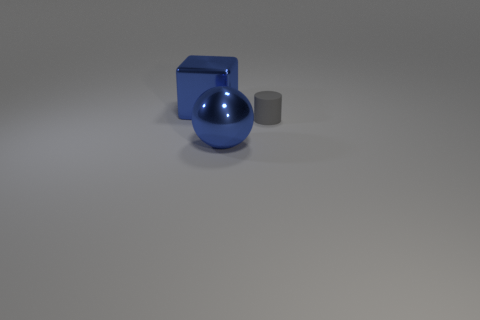Are there any tiny rubber objects in front of the gray matte object?
Keep it short and to the point. No. What shape is the big blue object that is on the left side of the metal thing in front of the gray rubber thing?
Your answer should be very brief. Cube. Are there fewer blue metal cubes that are right of the large blue metallic block than big blocks in front of the metal sphere?
Offer a very short reply. No. What number of things are left of the gray matte cylinder and right of the cube?
Provide a short and direct response. 1. Are there more spheres on the right side of the large blue ball than large blocks in front of the rubber object?
Offer a terse response. No. What is the size of the rubber thing?
Ensure brevity in your answer.  Small. Are there any blue metal things that have the same shape as the small gray object?
Provide a succinct answer. No. There is a gray rubber thing; is its shape the same as the large blue metallic thing in front of the blue metallic cube?
Provide a short and direct response. No. How big is the object that is behind the large ball and on the right side of the big cube?
Make the answer very short. Small. What number of small brown cylinders are there?
Provide a short and direct response. 0. 